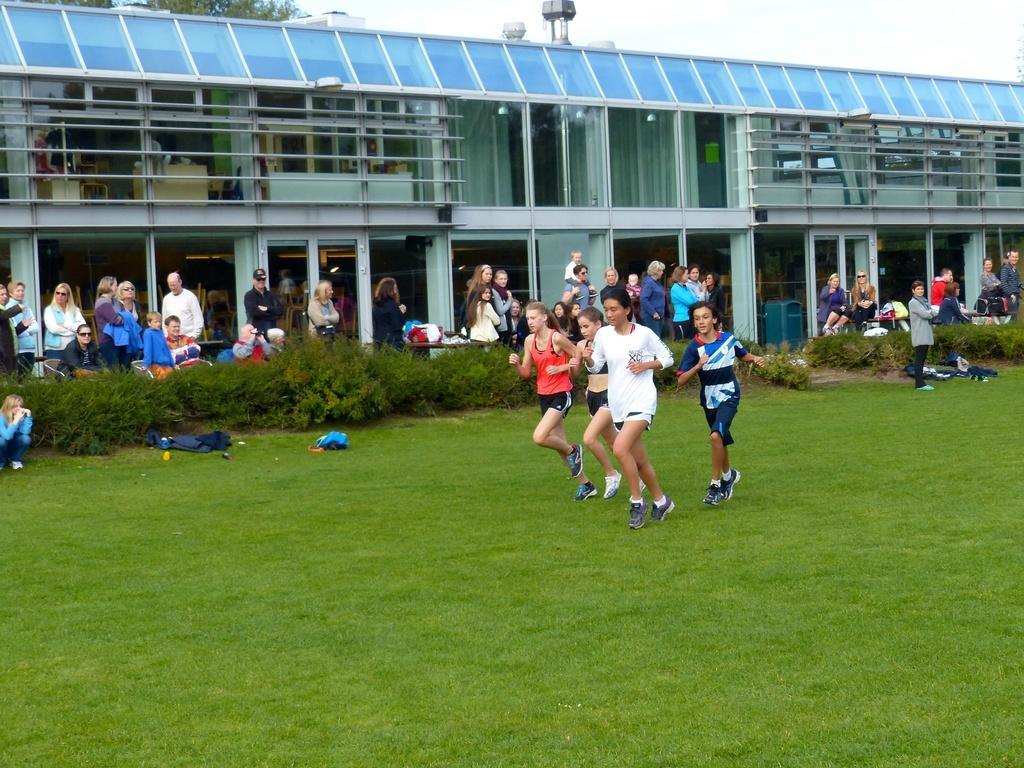Describe this image in one or two sentences. In this image we can see people. At the bottom there is grass and we can see plants. In the background there is a building and we can see trees. There is sky. We can see clothes. 